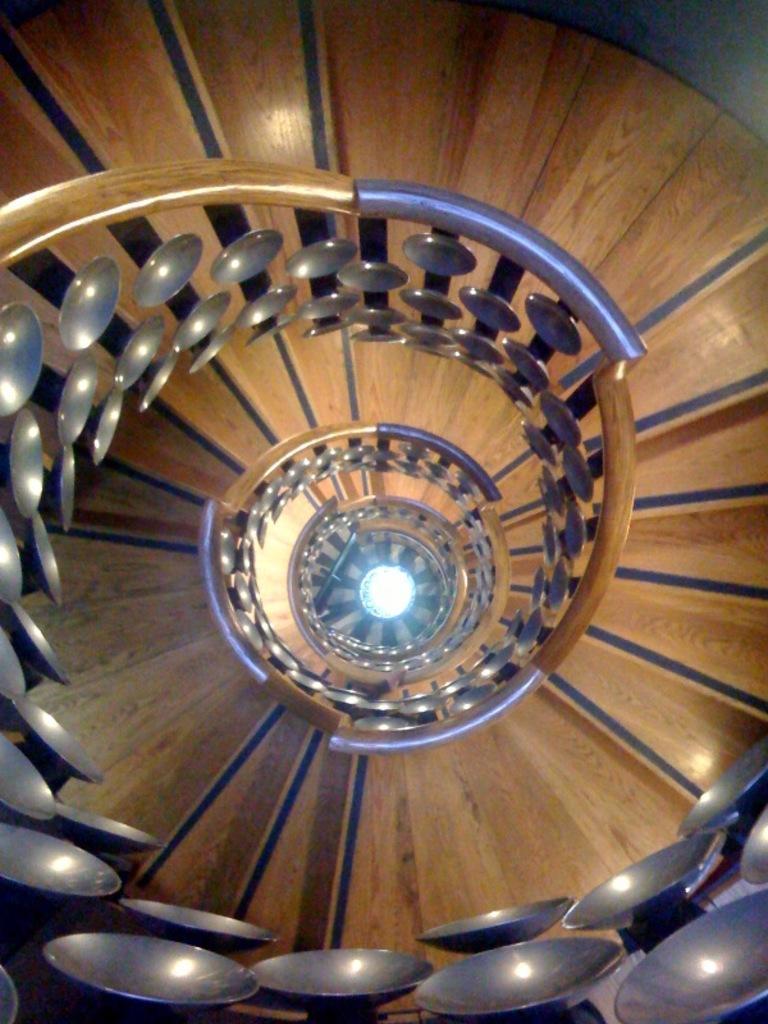Can you describe this image briefly? In this image we can see a wooden staircase, and there is a light. 